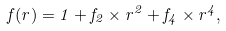Convert formula to latex. <formula><loc_0><loc_0><loc_500><loc_500>f ( r ) = 1 + f _ { 2 } \times r ^ { 2 } + f _ { 4 } \times r ^ { 4 } ,</formula> 